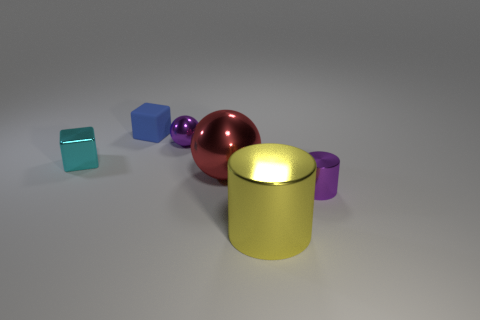Add 4 large yellow cylinders. How many objects exist? 10 Subtract all cylinders. How many objects are left? 4 Add 5 yellow things. How many yellow things exist? 6 Subtract 0 green cylinders. How many objects are left? 6 Subtract all big yellow shiny spheres. Subtract all tiny metallic balls. How many objects are left? 5 Add 4 shiny things. How many shiny things are left? 9 